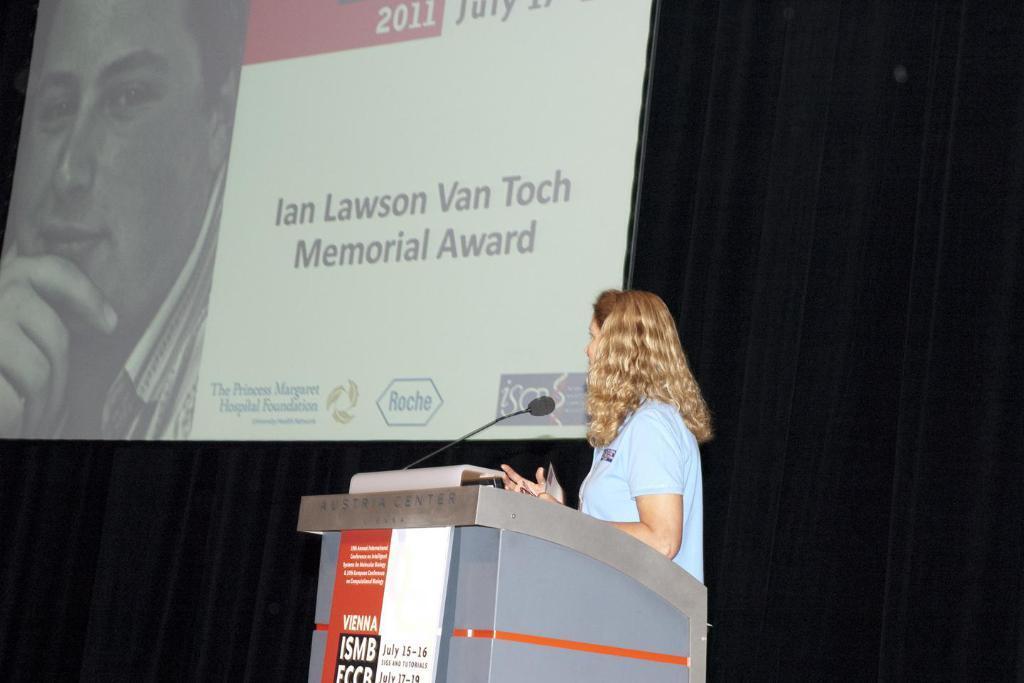Could you give a brief overview of what you see in this image? In this image we can see a person. In front of the person we can see a podium with mic and on the podium, we can see a board with text. Behind the person there is a projected screen. On the screen there is an image of a person and some text. 